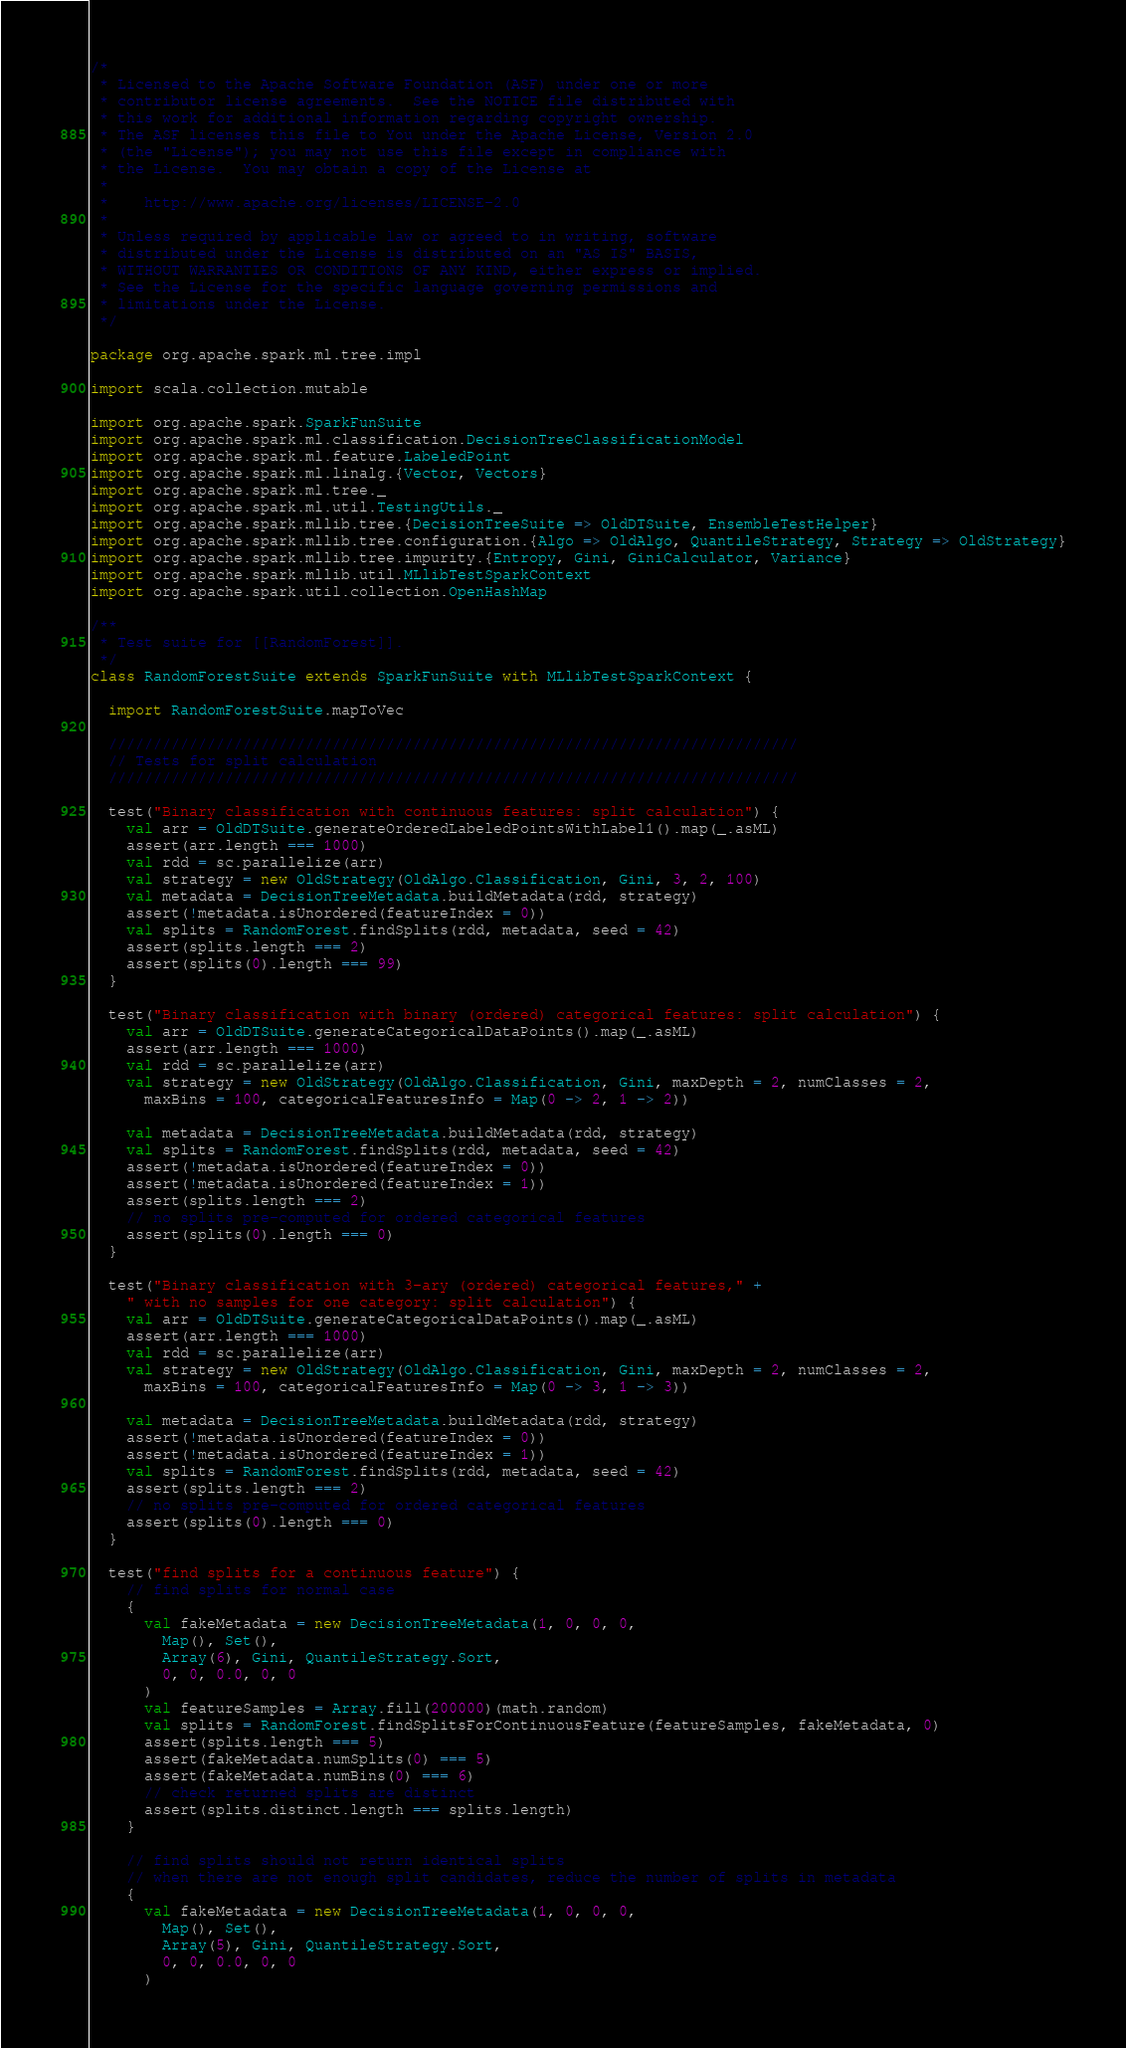Convert code to text. <code><loc_0><loc_0><loc_500><loc_500><_Scala_>/*
 * Licensed to the Apache Software Foundation (ASF) under one or more
 * contributor license agreements.  See the NOTICE file distributed with
 * this work for additional information regarding copyright ownership.
 * The ASF licenses this file to You under the Apache License, Version 2.0
 * (the "License"); you may not use this file except in compliance with
 * the License.  You may obtain a copy of the License at
 *
 *    http://www.apache.org/licenses/LICENSE-2.0
 *
 * Unless required by applicable law or agreed to in writing, software
 * distributed under the License is distributed on an "AS IS" BASIS,
 * WITHOUT WARRANTIES OR CONDITIONS OF ANY KIND, either express or implied.
 * See the License for the specific language governing permissions and
 * limitations under the License.
 */

package org.apache.spark.ml.tree.impl

import scala.collection.mutable

import org.apache.spark.SparkFunSuite
import org.apache.spark.ml.classification.DecisionTreeClassificationModel
import org.apache.spark.ml.feature.LabeledPoint
import org.apache.spark.ml.linalg.{Vector, Vectors}
import org.apache.spark.ml.tree._
import org.apache.spark.ml.util.TestingUtils._
import org.apache.spark.mllib.tree.{DecisionTreeSuite => OldDTSuite, EnsembleTestHelper}
import org.apache.spark.mllib.tree.configuration.{Algo => OldAlgo, QuantileStrategy, Strategy => OldStrategy}
import org.apache.spark.mllib.tree.impurity.{Entropy, Gini, GiniCalculator, Variance}
import org.apache.spark.mllib.util.MLlibTestSparkContext
import org.apache.spark.util.collection.OpenHashMap

/**
 * Test suite for [[RandomForest]].
 */
class RandomForestSuite extends SparkFunSuite with MLlibTestSparkContext {

  import RandomForestSuite.mapToVec

  /////////////////////////////////////////////////////////////////////////////
  // Tests for split calculation
  /////////////////////////////////////////////////////////////////////////////

  test("Binary classification with continuous features: split calculation") {
    val arr = OldDTSuite.generateOrderedLabeledPointsWithLabel1().map(_.asML)
    assert(arr.length === 1000)
    val rdd = sc.parallelize(arr)
    val strategy = new OldStrategy(OldAlgo.Classification, Gini, 3, 2, 100)
    val metadata = DecisionTreeMetadata.buildMetadata(rdd, strategy)
    assert(!metadata.isUnordered(featureIndex = 0))
    val splits = RandomForest.findSplits(rdd, metadata, seed = 42)
    assert(splits.length === 2)
    assert(splits(0).length === 99)
  }

  test("Binary classification with binary (ordered) categorical features: split calculation") {
    val arr = OldDTSuite.generateCategoricalDataPoints().map(_.asML)
    assert(arr.length === 1000)
    val rdd = sc.parallelize(arr)
    val strategy = new OldStrategy(OldAlgo.Classification, Gini, maxDepth = 2, numClasses = 2,
      maxBins = 100, categoricalFeaturesInfo = Map(0 -> 2, 1 -> 2))

    val metadata = DecisionTreeMetadata.buildMetadata(rdd, strategy)
    val splits = RandomForest.findSplits(rdd, metadata, seed = 42)
    assert(!metadata.isUnordered(featureIndex = 0))
    assert(!metadata.isUnordered(featureIndex = 1))
    assert(splits.length === 2)
    // no splits pre-computed for ordered categorical features
    assert(splits(0).length === 0)
  }

  test("Binary classification with 3-ary (ordered) categorical features," +
    " with no samples for one category: split calculation") {
    val arr = OldDTSuite.generateCategoricalDataPoints().map(_.asML)
    assert(arr.length === 1000)
    val rdd = sc.parallelize(arr)
    val strategy = new OldStrategy(OldAlgo.Classification, Gini, maxDepth = 2, numClasses = 2,
      maxBins = 100, categoricalFeaturesInfo = Map(0 -> 3, 1 -> 3))

    val metadata = DecisionTreeMetadata.buildMetadata(rdd, strategy)
    assert(!metadata.isUnordered(featureIndex = 0))
    assert(!metadata.isUnordered(featureIndex = 1))
    val splits = RandomForest.findSplits(rdd, metadata, seed = 42)
    assert(splits.length === 2)
    // no splits pre-computed for ordered categorical features
    assert(splits(0).length === 0)
  }

  test("find splits for a continuous feature") {
    // find splits for normal case
    {
      val fakeMetadata = new DecisionTreeMetadata(1, 0, 0, 0,
        Map(), Set(),
        Array(6), Gini, QuantileStrategy.Sort,
        0, 0, 0.0, 0, 0
      )
      val featureSamples = Array.fill(200000)(math.random)
      val splits = RandomForest.findSplitsForContinuousFeature(featureSamples, fakeMetadata, 0)
      assert(splits.length === 5)
      assert(fakeMetadata.numSplits(0) === 5)
      assert(fakeMetadata.numBins(0) === 6)
      // check returned splits are distinct
      assert(splits.distinct.length === splits.length)
    }

    // find splits should not return identical splits
    // when there are not enough split candidates, reduce the number of splits in metadata
    {
      val fakeMetadata = new DecisionTreeMetadata(1, 0, 0, 0,
        Map(), Set(),
        Array(5), Gini, QuantileStrategy.Sort,
        0, 0, 0.0, 0, 0
      )</code> 